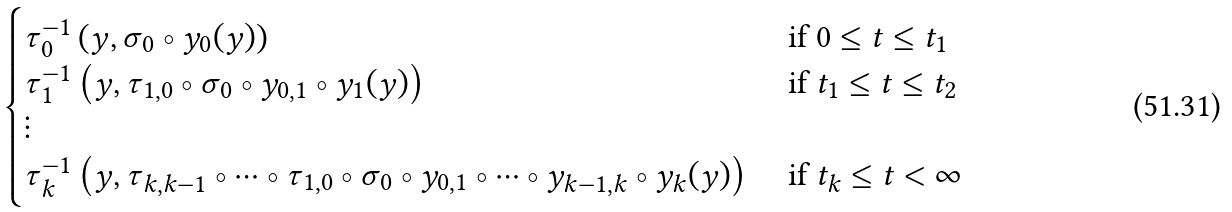Convert formula to latex. <formula><loc_0><loc_0><loc_500><loc_500>\begin{cases} \tau _ { 0 } ^ { - 1 } \left ( y , \sigma _ { 0 } \circ y _ { 0 } ( y ) \right ) & \text { if $0\leq t\leq t_{1}$} \\ \tau _ { 1 } ^ { - 1 } \left ( y , \tau _ { 1 , 0 } \circ \sigma _ { 0 } \circ y _ { 0 , 1 } \circ y _ { 1 } ( y ) \right ) & \text { if $t_{1}\leq t\leq t_{2}$} \\ \vdots \\ \tau _ { k } ^ { - 1 } \left ( y , \tau _ { k , k - 1 } \circ \cdots \circ \tau _ { 1 , 0 } \circ \sigma _ { 0 } \circ y _ { 0 , 1 } \circ \cdots \circ y _ { k - 1 , k } \circ y _ { k } ( y ) \right ) & \text { if $t_{k}\leq t < \infty$} \end{cases}</formula> 